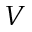Convert formula to latex. <formula><loc_0><loc_0><loc_500><loc_500>V</formula> 